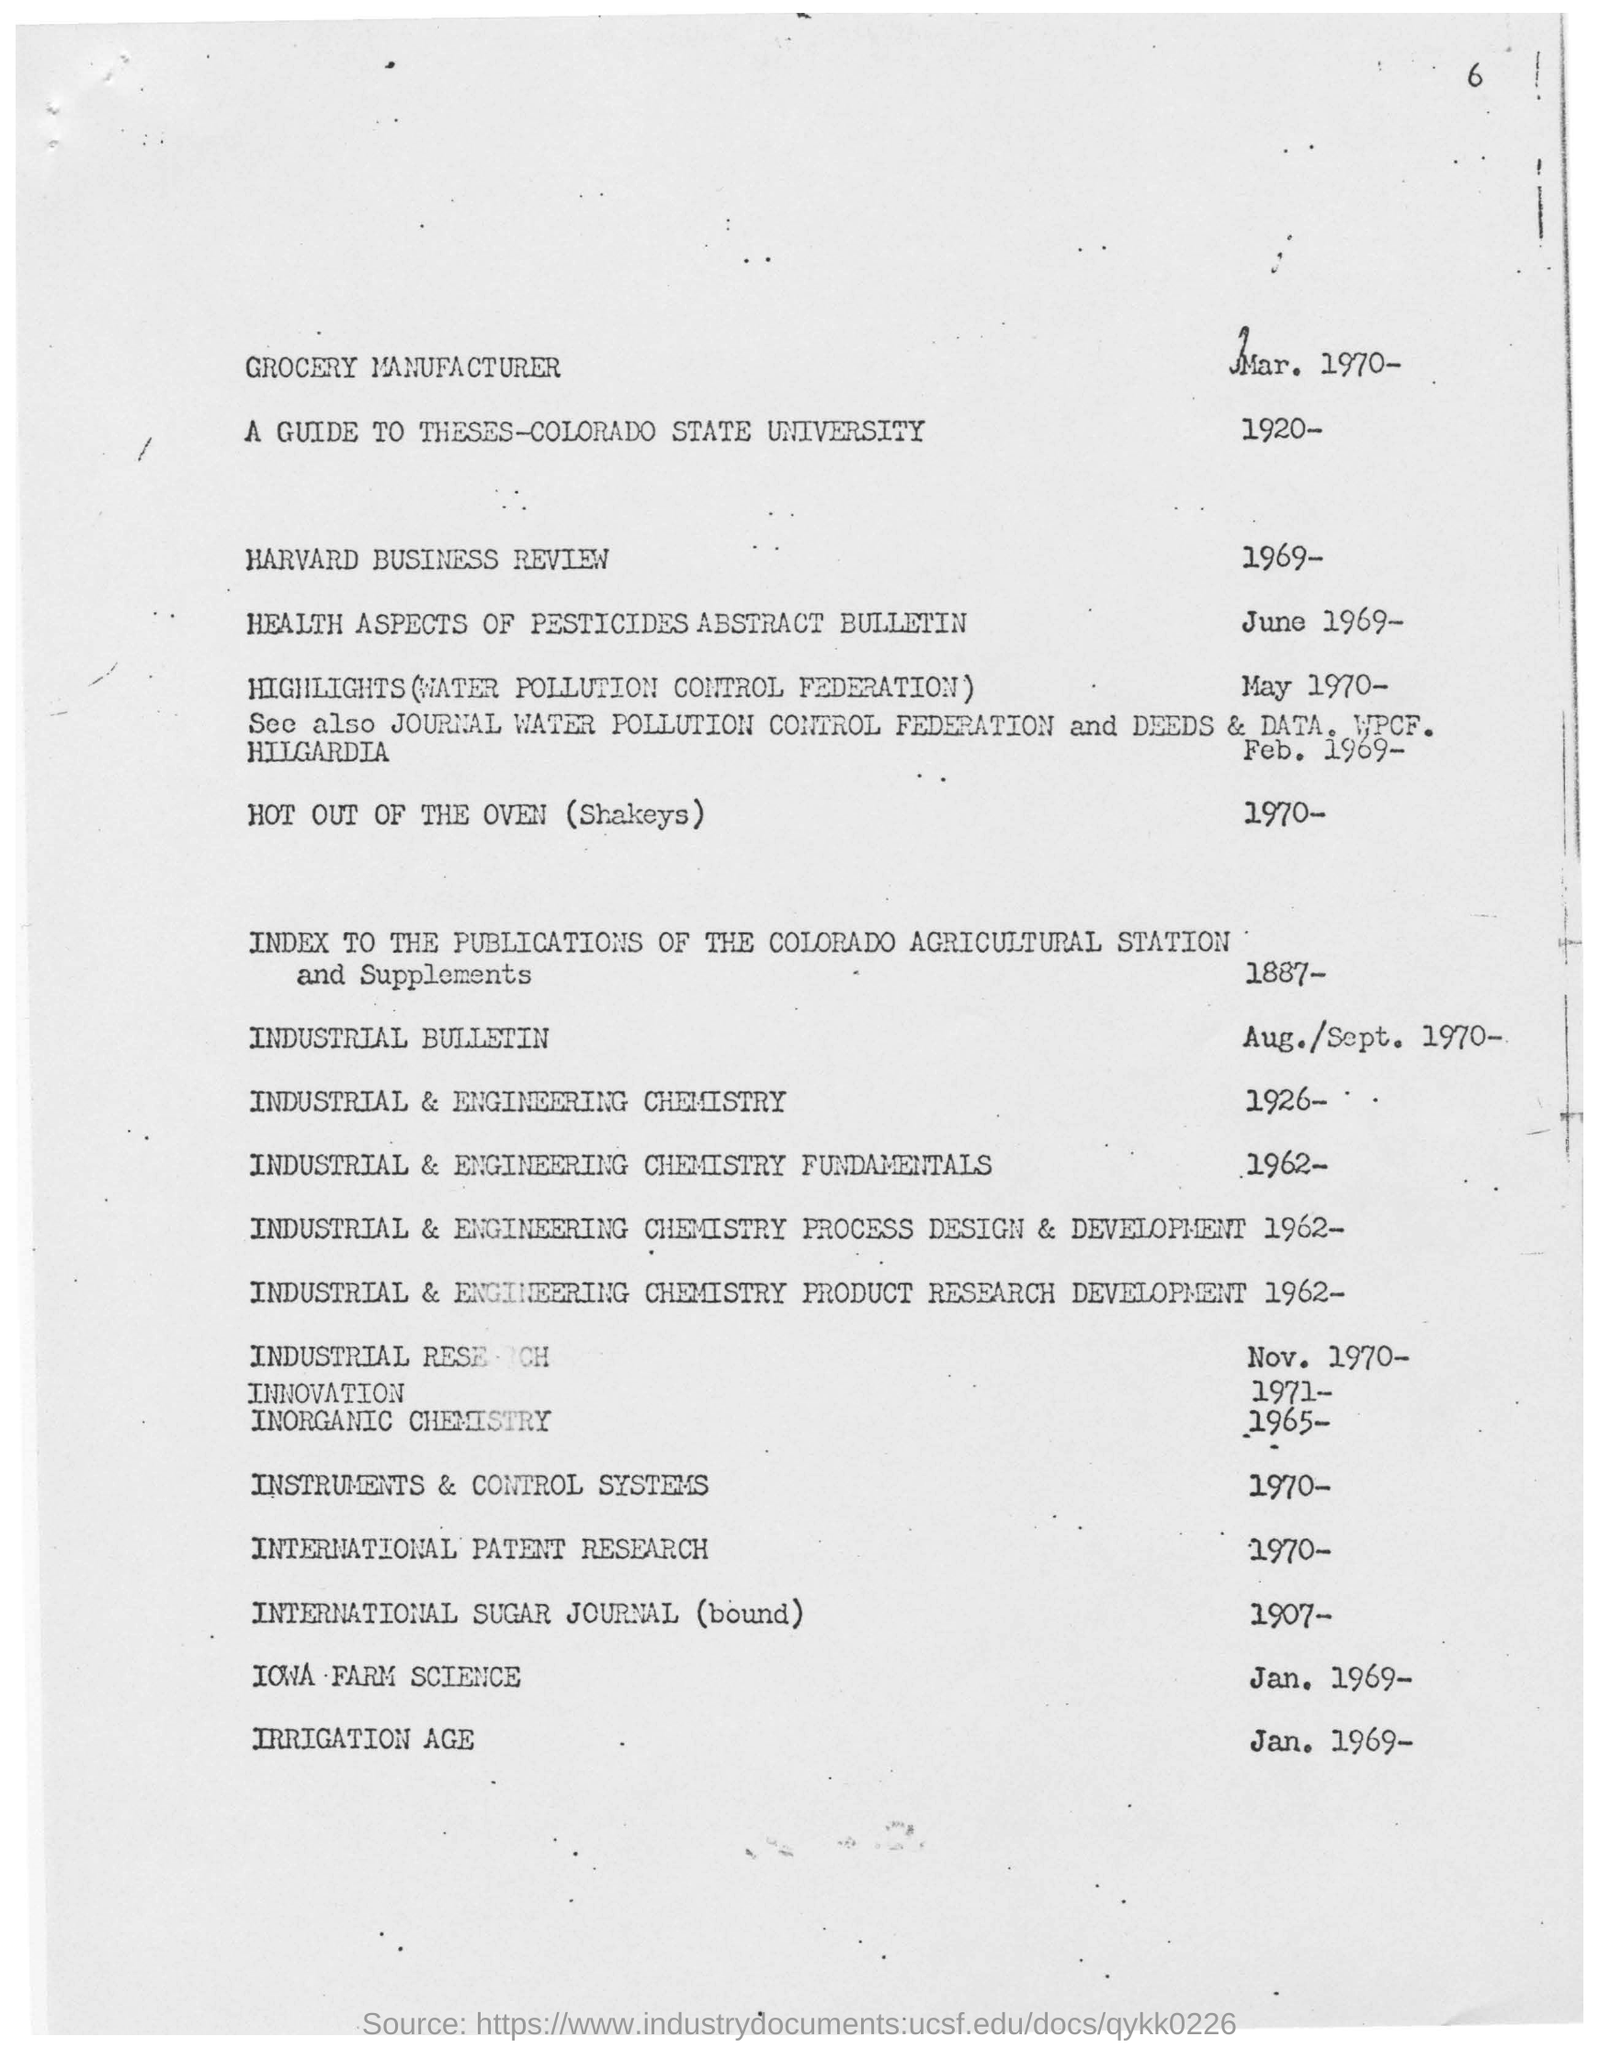Highlight a few significant elements in this photo. The year mentioned for the grocery manufacturer is 1970. The irrigation age mentioned in the given page is 1969. According to the information provided for IOWA-Farm science in January 1969, the year is mentioned. The year mentioned in the Harvard Business Review is 1969. 